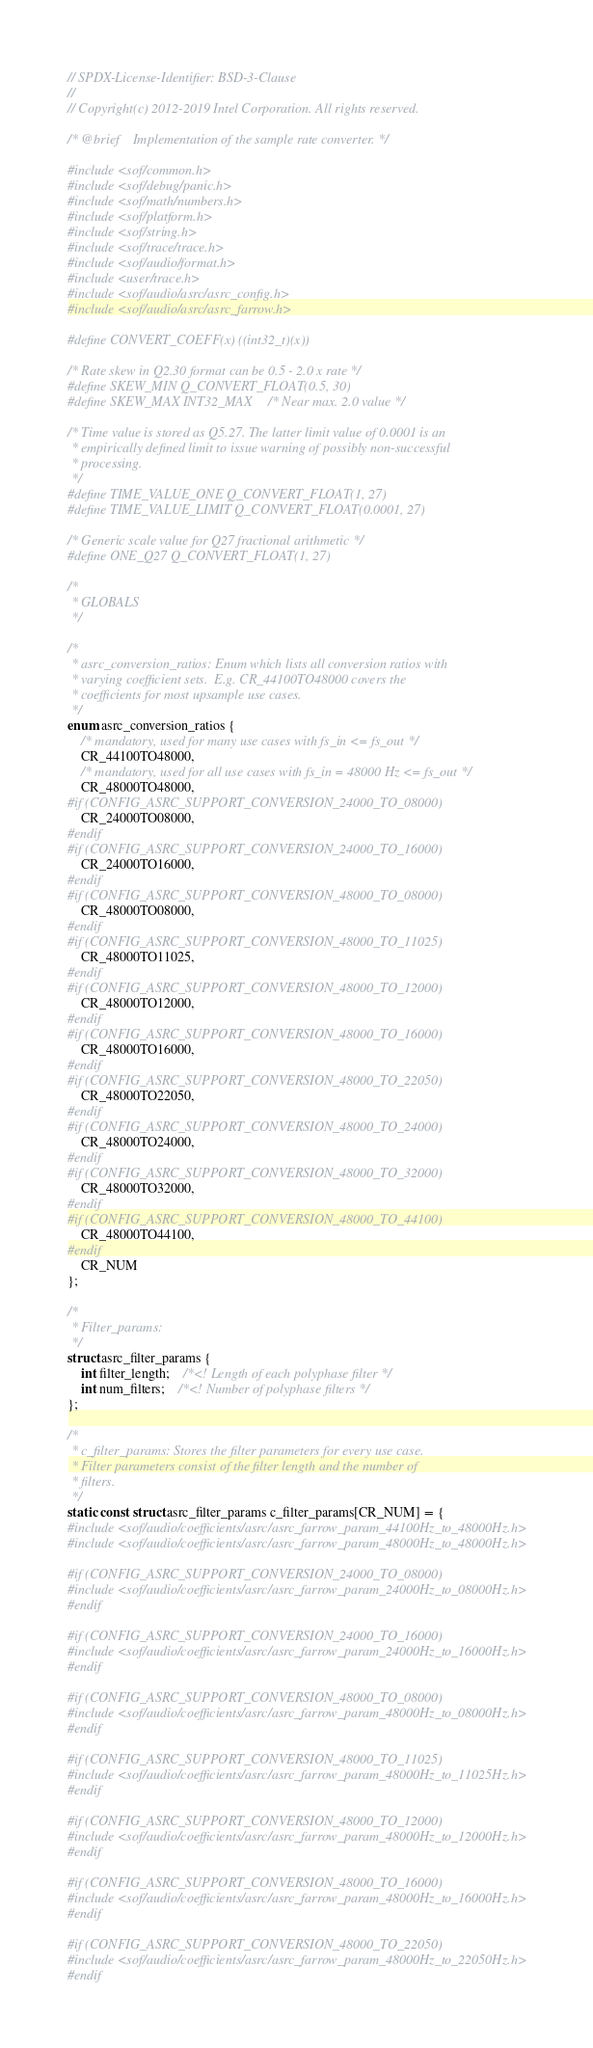Convert code to text. <code><loc_0><loc_0><loc_500><loc_500><_C_>// SPDX-License-Identifier: BSD-3-Clause
//
// Copyright(c) 2012-2019 Intel Corporation. All rights reserved.

/* @brief    Implementation of the sample rate converter. */

#include <sof/common.h>
#include <sof/debug/panic.h>
#include <sof/math/numbers.h>
#include <sof/platform.h>
#include <sof/string.h>
#include <sof/trace/trace.h>
#include <sof/audio/format.h>
#include <user/trace.h>
#include <sof/audio/asrc/asrc_config.h>
#include <sof/audio/asrc/asrc_farrow.h>

#define CONVERT_COEFF(x) ((int32_t)(x))

/* Rate skew in Q2.30 format can be 0.5 - 2.0 x rate */
#define SKEW_MIN Q_CONVERT_FLOAT(0.5, 30)
#define SKEW_MAX INT32_MAX /* Near max. 2.0 value */

/* Time value is stored as Q5.27. The latter limit value of 0.0001 is an
 * empirically defined limit to issue warning of possibly non-successful
 * processing.
 */
#define TIME_VALUE_ONE Q_CONVERT_FLOAT(1, 27)
#define TIME_VALUE_LIMIT Q_CONVERT_FLOAT(0.0001, 27)

/* Generic scale value for Q27 fractional arithmetic */
#define ONE_Q27 Q_CONVERT_FLOAT(1, 27)

/*
 * GLOBALS
 */

/*
 * asrc_conversion_ratios: Enum which lists all conversion ratios with
 * varying coefficient sets.  E.g. CR_44100TO48000 covers the
 * coefficients for most upsample use cases.
 */
enum asrc_conversion_ratios {
	/* mandatory, used for many use cases with fs_in <= fs_out */
	CR_44100TO48000,
	/* mandatory, used for all use cases with fs_in = 48000 Hz <= fs_out */
	CR_48000TO48000,
#if (CONFIG_ASRC_SUPPORT_CONVERSION_24000_TO_08000)
	CR_24000TO08000,
#endif
#if (CONFIG_ASRC_SUPPORT_CONVERSION_24000_TO_16000)
	CR_24000TO16000,
#endif
#if (CONFIG_ASRC_SUPPORT_CONVERSION_48000_TO_08000)
	CR_48000TO08000,
#endif
#if (CONFIG_ASRC_SUPPORT_CONVERSION_48000_TO_11025)
	CR_48000TO11025,
#endif
#if (CONFIG_ASRC_SUPPORT_CONVERSION_48000_TO_12000)
	CR_48000TO12000,
#endif
#if (CONFIG_ASRC_SUPPORT_CONVERSION_48000_TO_16000)
	CR_48000TO16000,
#endif
#if (CONFIG_ASRC_SUPPORT_CONVERSION_48000_TO_22050)
	CR_48000TO22050,
#endif
#if (CONFIG_ASRC_SUPPORT_CONVERSION_48000_TO_24000)
	CR_48000TO24000,
#endif
#if (CONFIG_ASRC_SUPPORT_CONVERSION_48000_TO_32000)
	CR_48000TO32000,
#endif
#if (CONFIG_ASRC_SUPPORT_CONVERSION_48000_TO_44100)
	CR_48000TO44100,
#endif
	CR_NUM
};

/*
 * Filter_params:
 */
struct asrc_filter_params {
	int filter_length;	/*<! Length of each polyphase filter */
	int num_filters;	/*<! Number of polyphase filters */
};

/*
 * c_filter_params: Stores the filter parameters for every use case.
 * Filter parameters consist of the filter length and the number of
 * filters.
 */
static const struct asrc_filter_params c_filter_params[CR_NUM] = {
#include <sof/audio/coefficients/asrc/asrc_farrow_param_44100Hz_to_48000Hz.h>
#include <sof/audio/coefficients/asrc/asrc_farrow_param_48000Hz_to_48000Hz.h>

#if (CONFIG_ASRC_SUPPORT_CONVERSION_24000_TO_08000)
#include <sof/audio/coefficients/asrc/asrc_farrow_param_24000Hz_to_08000Hz.h>
#endif

#if (CONFIG_ASRC_SUPPORT_CONVERSION_24000_TO_16000)
#include <sof/audio/coefficients/asrc/asrc_farrow_param_24000Hz_to_16000Hz.h>
#endif

#if (CONFIG_ASRC_SUPPORT_CONVERSION_48000_TO_08000)
#include <sof/audio/coefficients/asrc/asrc_farrow_param_48000Hz_to_08000Hz.h>
#endif

#if (CONFIG_ASRC_SUPPORT_CONVERSION_48000_TO_11025)
#include <sof/audio/coefficients/asrc/asrc_farrow_param_48000Hz_to_11025Hz.h>
#endif

#if (CONFIG_ASRC_SUPPORT_CONVERSION_48000_TO_12000)
#include <sof/audio/coefficients/asrc/asrc_farrow_param_48000Hz_to_12000Hz.h>
#endif

#if (CONFIG_ASRC_SUPPORT_CONVERSION_48000_TO_16000)
#include <sof/audio/coefficients/asrc/asrc_farrow_param_48000Hz_to_16000Hz.h>
#endif

#if (CONFIG_ASRC_SUPPORT_CONVERSION_48000_TO_22050)
#include <sof/audio/coefficients/asrc/asrc_farrow_param_48000Hz_to_22050Hz.h>
#endif
</code> 